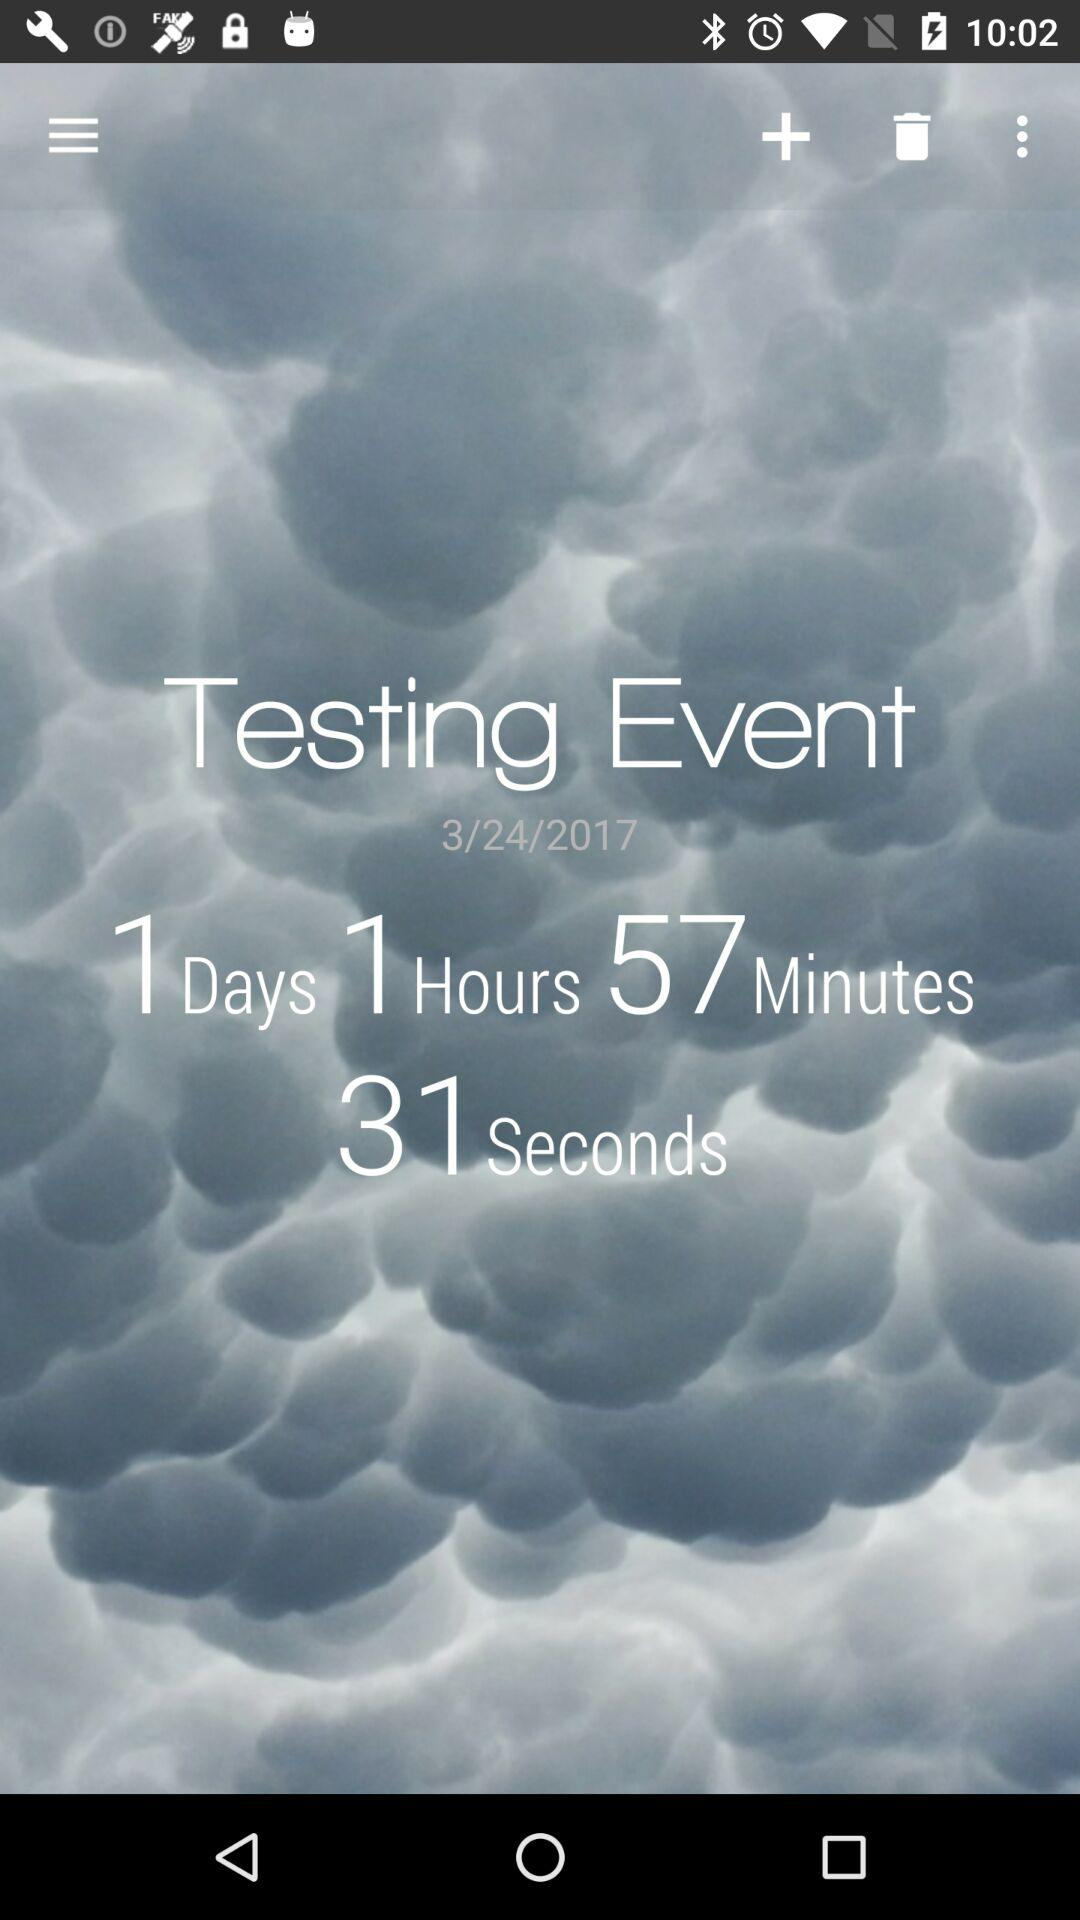How many days are left for the testing event? There is 1 day left for the testing event. 